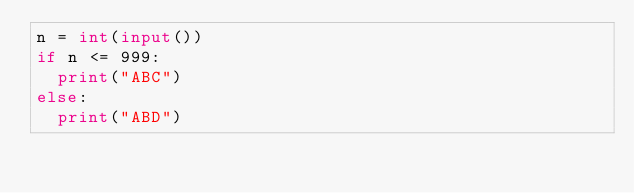Convert code to text. <code><loc_0><loc_0><loc_500><loc_500><_Python_>n = int(input())
if n <= 999:
  print("ABC")
else:
  print("ABD")</code> 